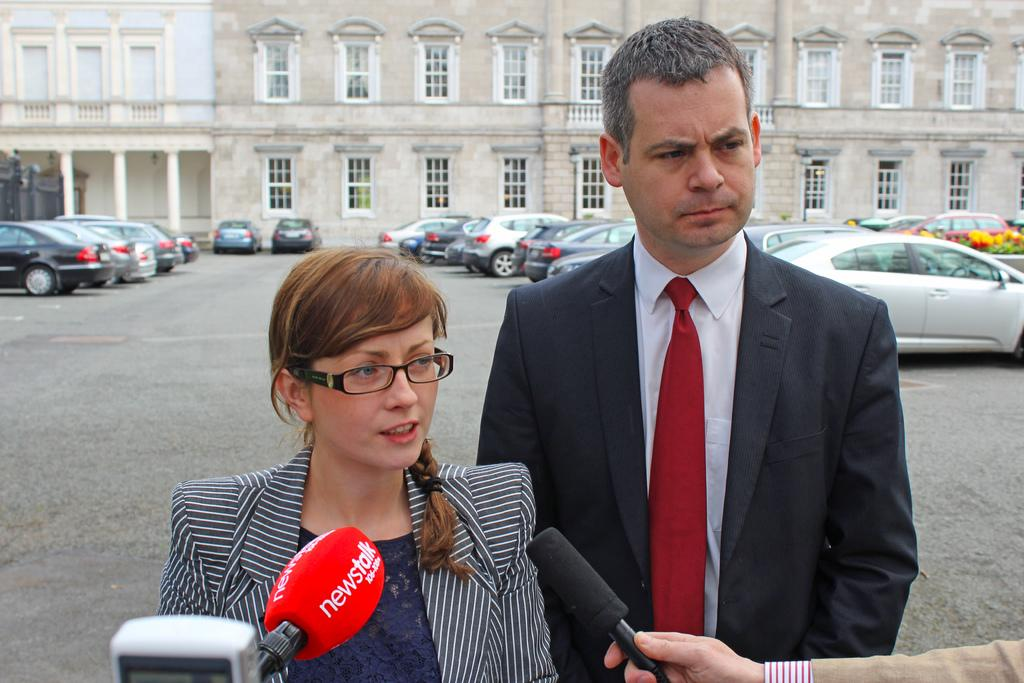How many people are present in the image? There are two people in the image. What are the two people doing in the image? The two people are talking in the mic. What can be seen in the background of the image? There is a building in the background of the image. What is a feature of the building in the image? The building has windows. What is visible near the building in the image? There are cars parked in front of the building. What grade did the person in the image receive for their performance? There is no indication of a performance or grade in the image; it simply shows two people talking in the mic. What type of zinc is present in the image? There is no zinc present in the image. 